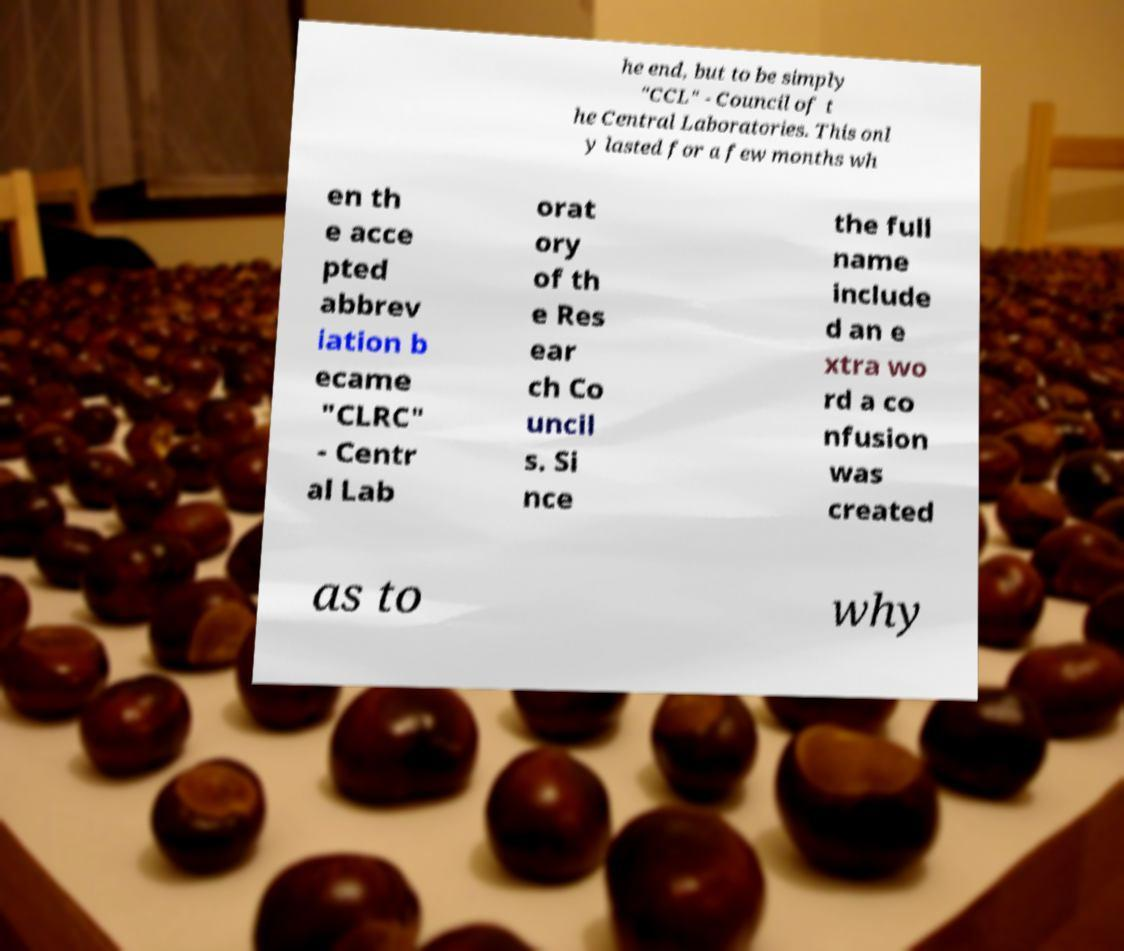Please read and relay the text visible in this image. What does it say? he end, but to be simply "CCL" - Council of t he Central Laboratories. This onl y lasted for a few months wh en th e acce pted abbrev iation b ecame "CLRC" - Centr al Lab orat ory of th e Res ear ch Co uncil s. Si nce the full name include d an e xtra wo rd a co nfusion was created as to why 